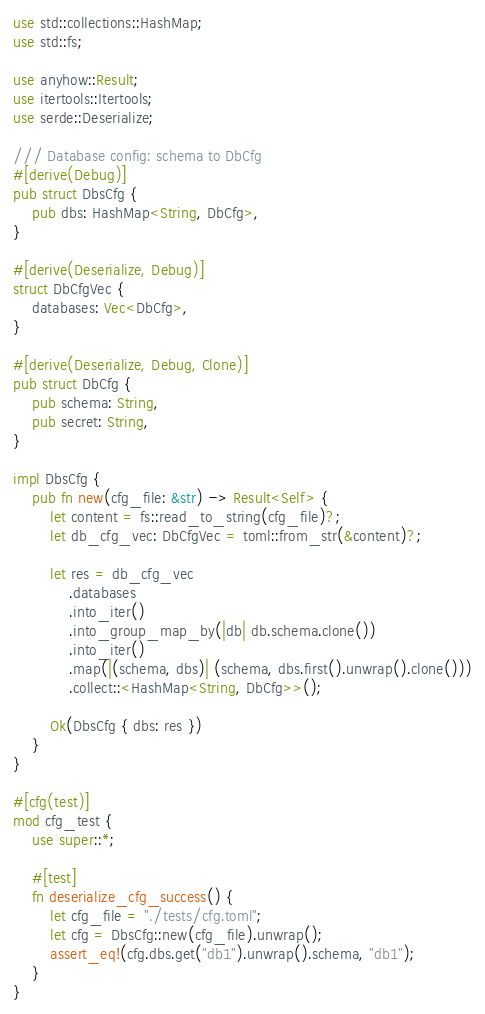Convert code to text. <code><loc_0><loc_0><loc_500><loc_500><_Rust_>use std::collections::HashMap;
use std::fs;

use anyhow::Result;
use itertools::Itertools;
use serde::Deserialize;

/// Database config: schema to DbCfg
#[derive(Debug)]
pub struct DbsCfg {
    pub dbs: HashMap<String, DbCfg>,
}

#[derive(Deserialize, Debug)]
struct DbCfgVec {
    databases: Vec<DbCfg>,
}

#[derive(Deserialize, Debug, Clone)]
pub struct DbCfg {
    pub schema: String,
    pub secret: String,
}

impl DbsCfg {
    pub fn new(cfg_file: &str) -> Result<Self> {
        let content = fs::read_to_string(cfg_file)?;
        let db_cfg_vec: DbCfgVec = toml::from_str(&content)?;

        let res = db_cfg_vec
            .databases
            .into_iter()
            .into_group_map_by(|db| db.schema.clone())
            .into_iter()
            .map(|(schema, dbs)| (schema, dbs.first().unwrap().clone()))
            .collect::<HashMap<String, DbCfg>>();

        Ok(DbsCfg { dbs: res })
    }
}

#[cfg(test)]
mod cfg_test {
    use super::*;

    #[test]
    fn deserialize_cfg_success() {
        let cfg_file = "./tests/cfg.toml";
        let cfg = DbsCfg::new(cfg_file).unwrap();
        assert_eq!(cfg.dbs.get("db1").unwrap().schema, "db1");
    }
}
</code> 